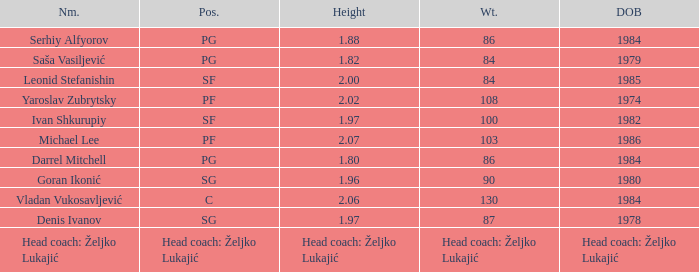Which position did Michael Lee play? PF. 